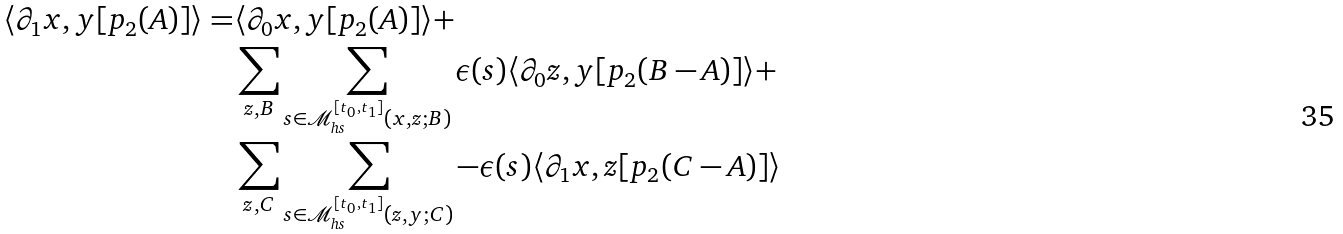Convert formula to latex. <formula><loc_0><loc_0><loc_500><loc_500>\langle \partial _ { 1 } x , y [ p _ { 2 } ( A ) ] \rangle = & \langle \partial _ { 0 } x , y [ p _ { 2 } ( A ) ] \rangle + \\ & \sum _ { z , B } \sum _ { s \in \mathcal { M } ^ { [ t _ { 0 } , t _ { 1 } ] } _ { h s } ( x , z ; B ) } \epsilon ( s ) \langle \partial _ { 0 } z , y [ p _ { 2 } ( B - A ) ] \rangle + \\ & \sum _ { z , C } \sum _ { s \in \mathcal { M } ^ { [ t _ { 0 } , t _ { 1 } ] } _ { h s } ( z , y ; C ) } - \epsilon ( s ) \langle \partial _ { 1 } x , z [ p _ { 2 } ( C - A ) ] \rangle</formula> 